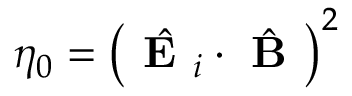Convert formula to latex. <formula><loc_0><loc_0><loc_500><loc_500>\eta _ { 0 } = \left ( \hat { E _ { i } } \cdot \hat { B } \right ) ^ { 2 }</formula> 